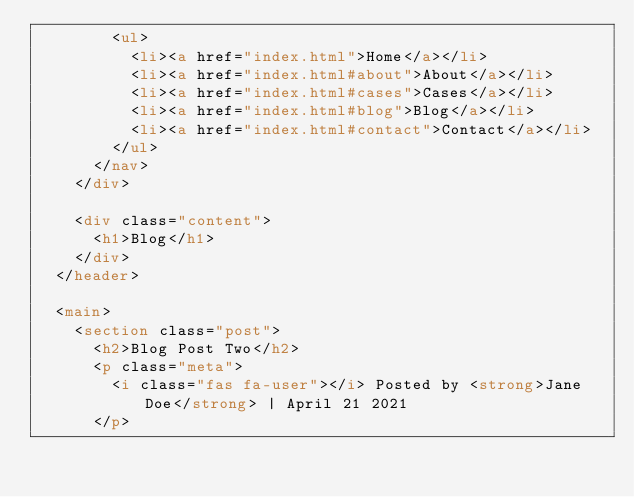Convert code to text. <code><loc_0><loc_0><loc_500><loc_500><_HTML_>        <ul>
          <li><a href="index.html">Home</a></li>
          <li><a href="index.html#about">About</a></li>
          <li><a href="index.html#cases">Cases</a></li>
          <li><a href="index.html#blog">Blog</a></li>
          <li><a href="index.html#contact">Contact</a></li>
        </ul>
      </nav>
    </div>

    <div class="content">
      <h1>Blog</h1>
    </div>
  </header>

  <main>
    <section class="post">
      <h2>Blog Post Two</h2>
      <p class="meta">
        <i class="fas fa-user"></i> Posted by <strong>Jane Doe</strong> | April 21 2021
      </p></code> 